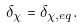Convert formula to latex. <formula><loc_0><loc_0><loc_500><loc_500>\delta _ { \chi } = \delta _ { \chi , e q } .</formula> 